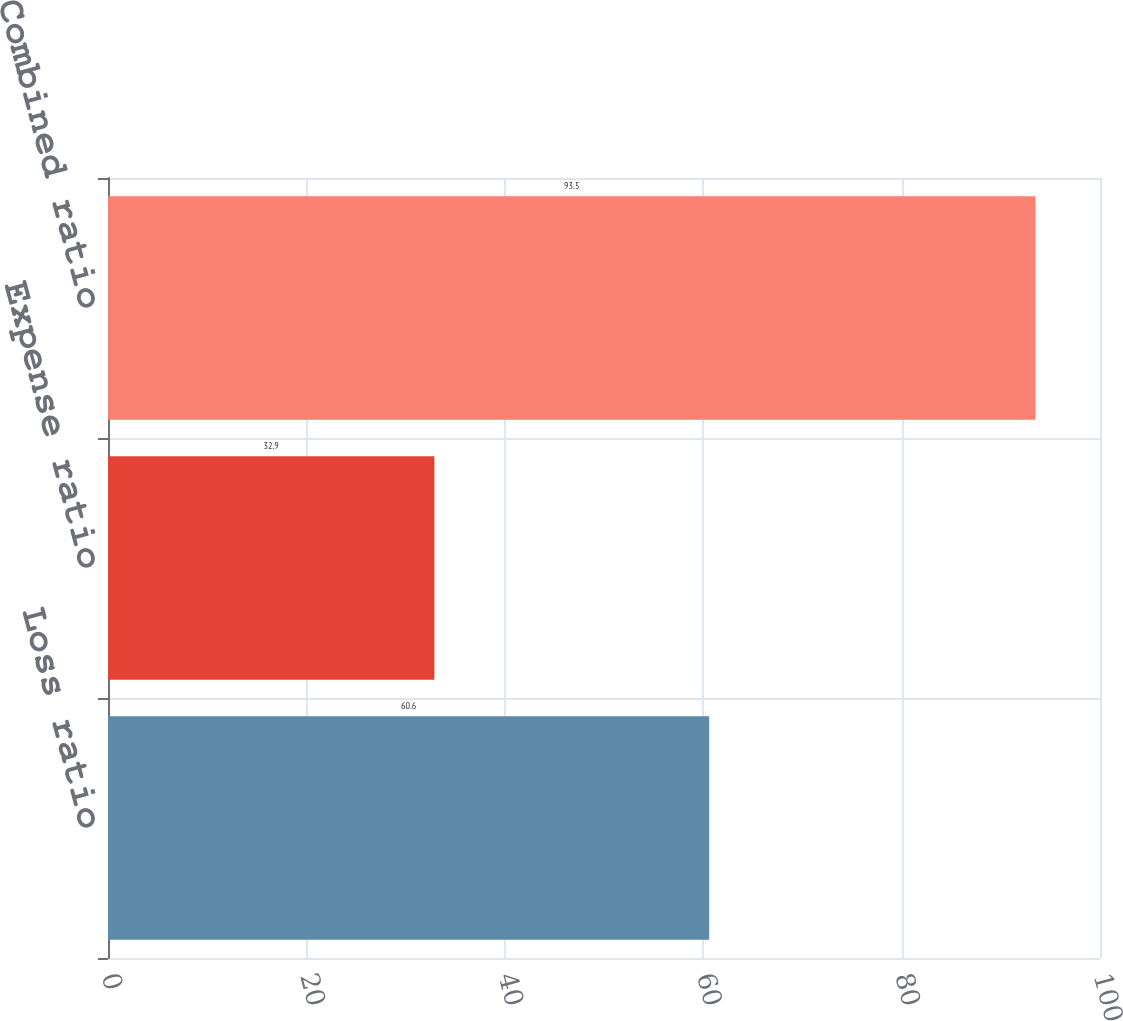Convert chart to OTSL. <chart><loc_0><loc_0><loc_500><loc_500><bar_chart><fcel>Loss ratio<fcel>Expense ratio<fcel>Combined ratio<nl><fcel>60.6<fcel>32.9<fcel>93.5<nl></chart> 